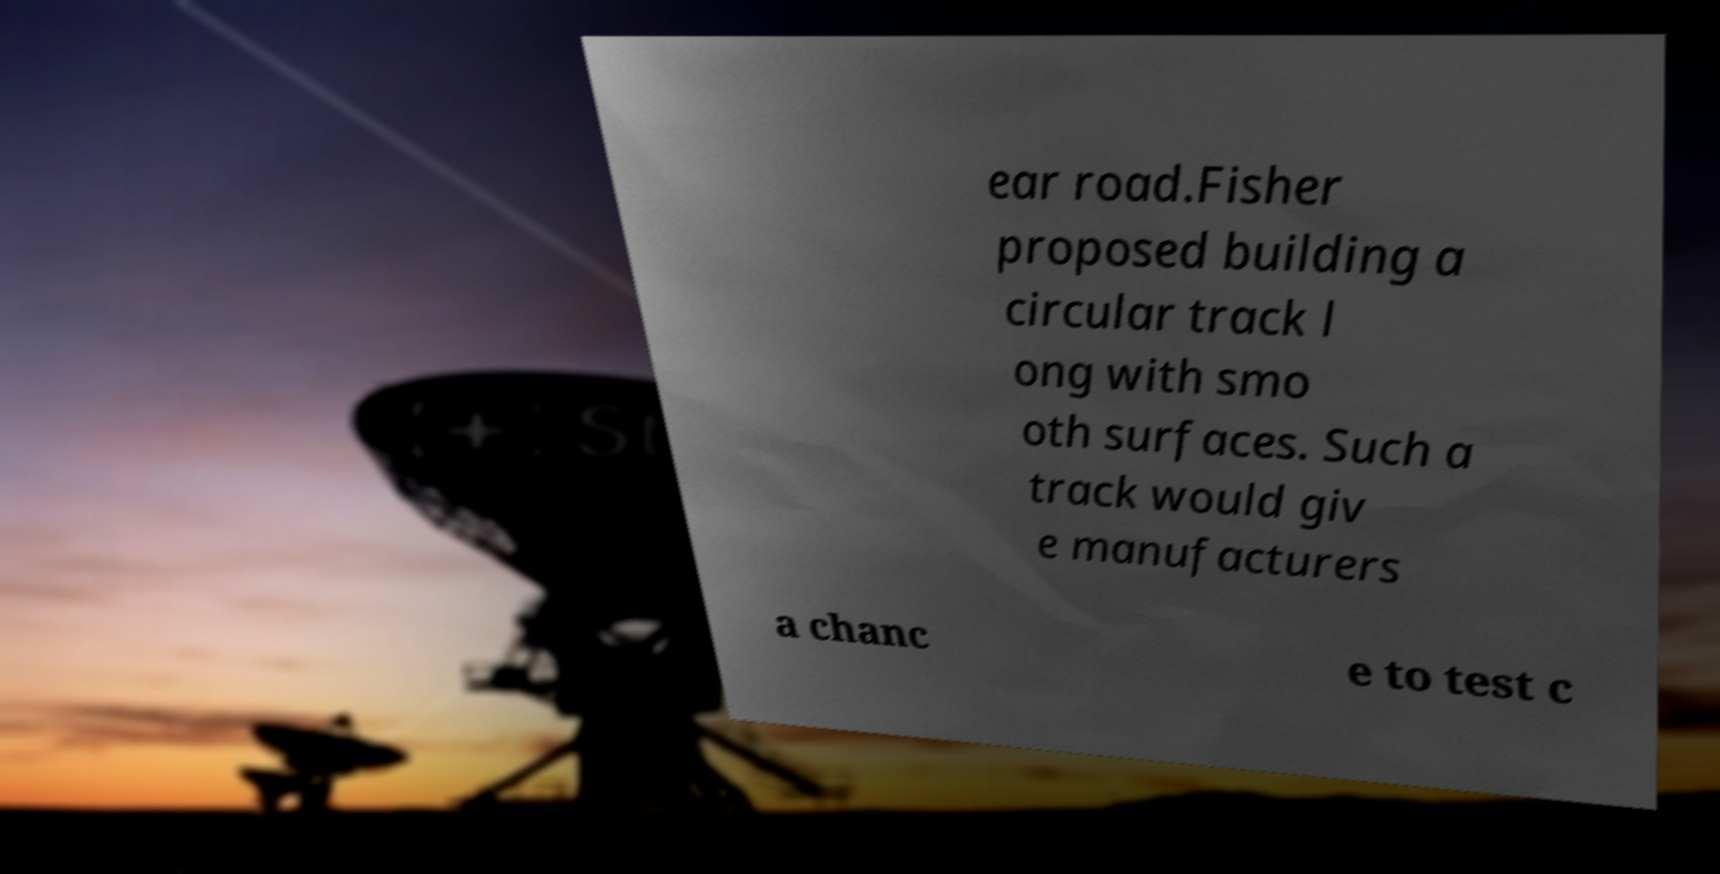Could you extract and type out the text from this image? ear road.Fisher proposed building a circular track l ong with smo oth surfaces. Such a track would giv e manufacturers a chanc e to test c 